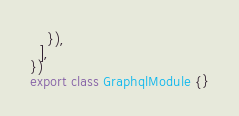<code> <loc_0><loc_0><loc_500><loc_500><_TypeScript_>    }),
  ],
})
export class GraphqlModule {}
</code> 